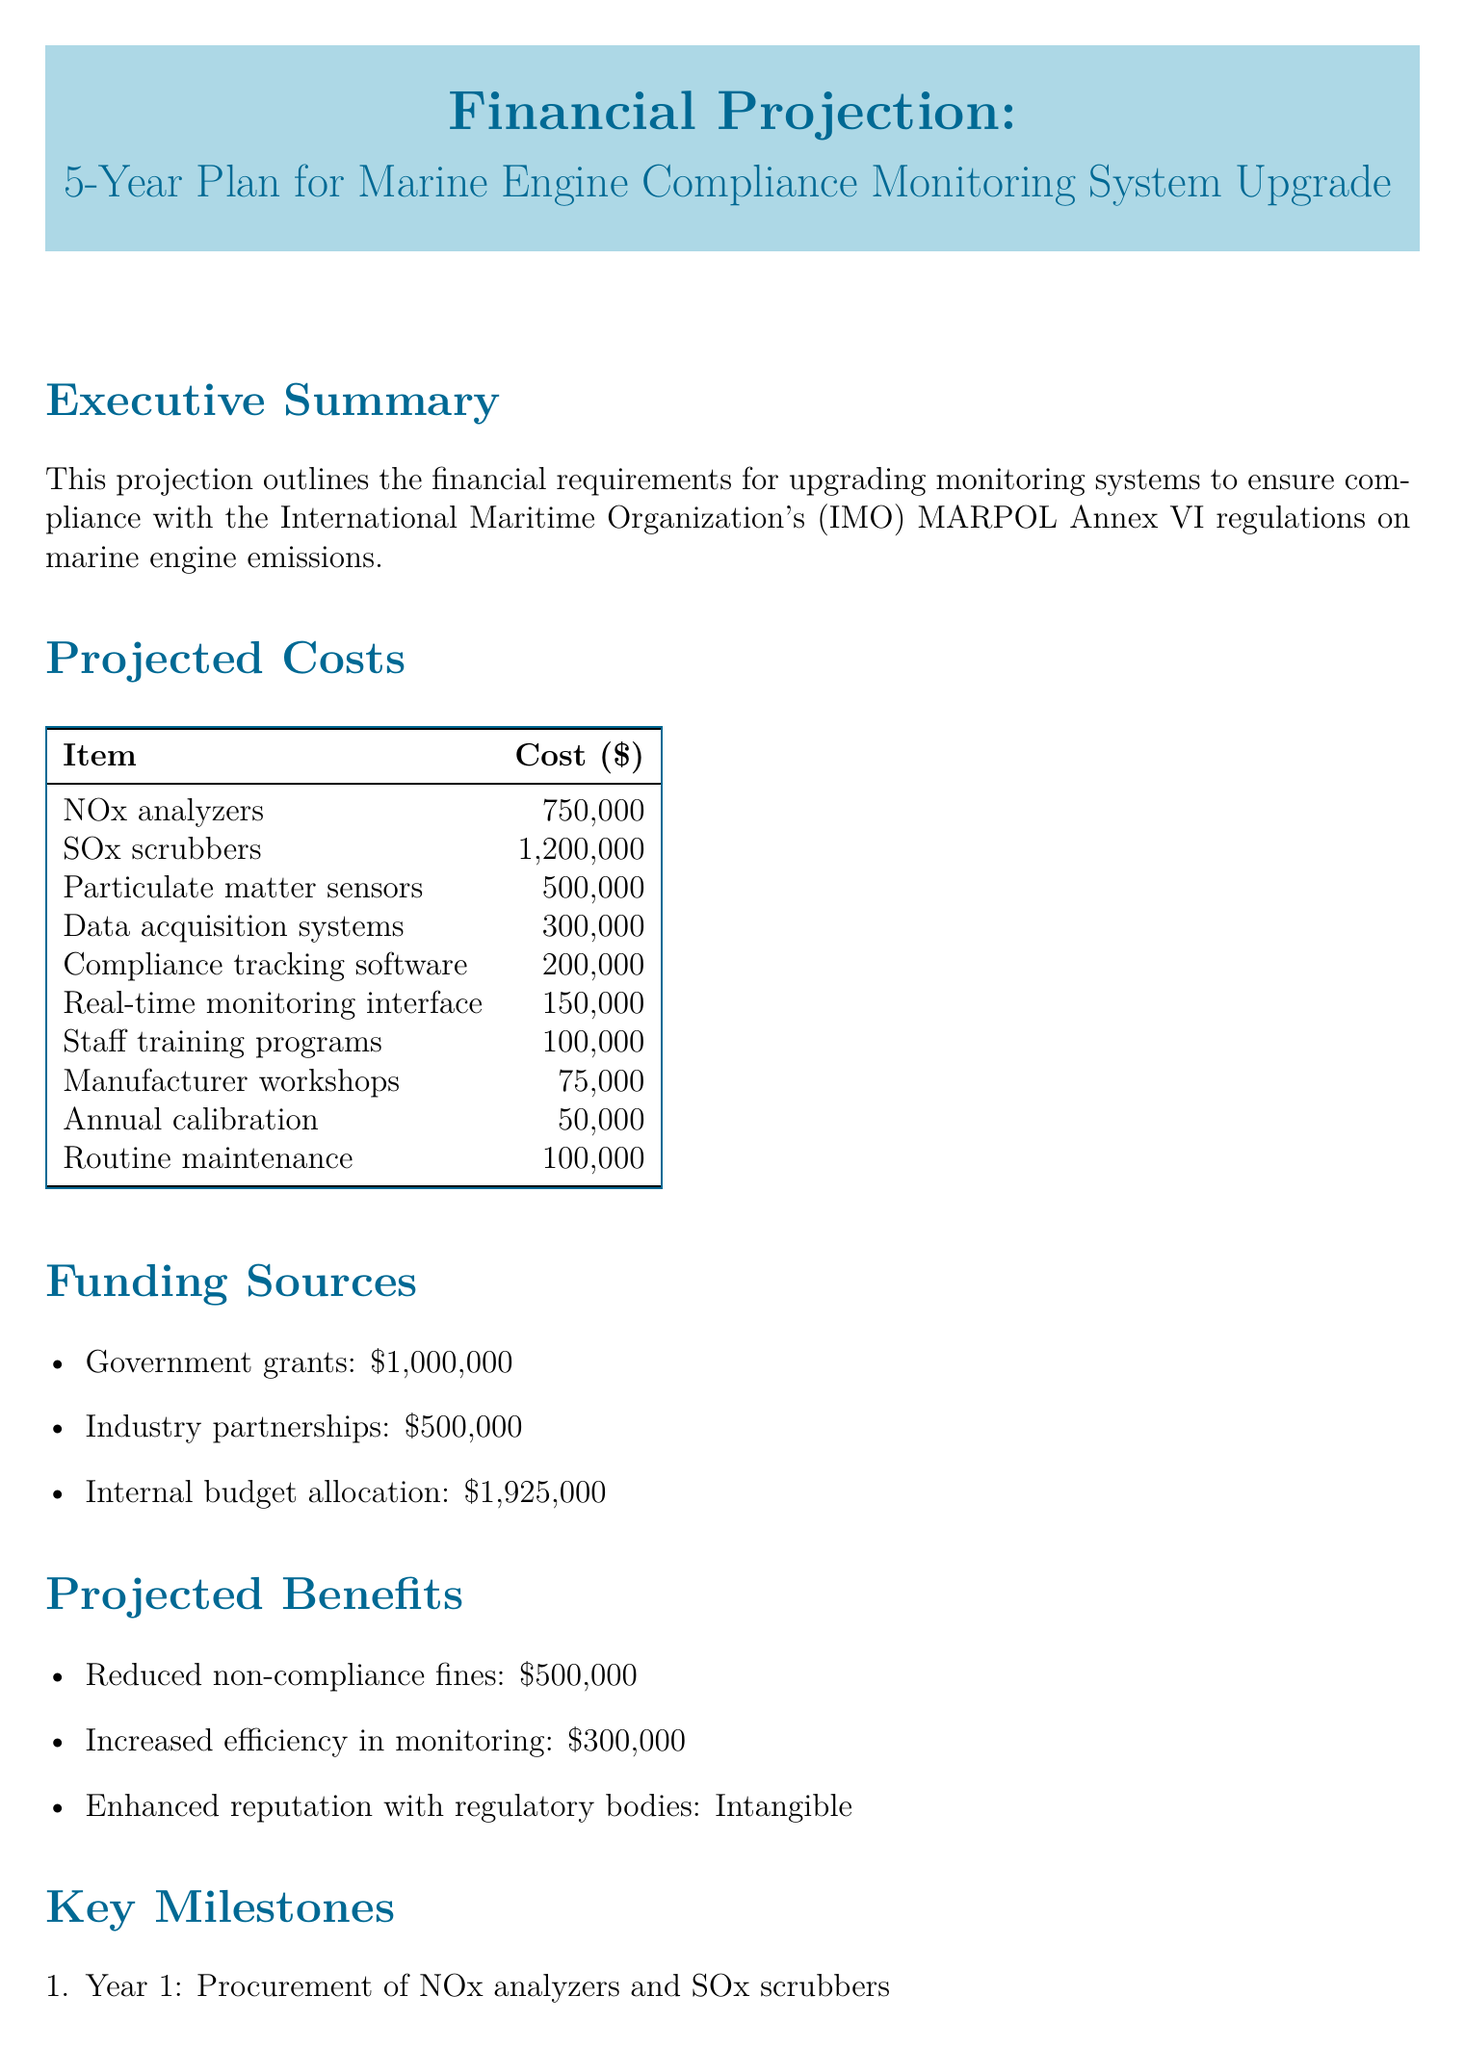What is the total cost of NOx analyzers? The cost for NOx analyzers is listed as $750,000 in the projected costs section.
Answer: $750,000 What is the funding source that contributes the most? The internal budget allocation is the largest funding source at $1,925,000.
Answer: $1,925,000 How much will be spent on staff training programs? Staff training programs will cost $100,000 as indicated in the projected costs section.
Answer: $100,000 What is the projected benefit from reduced non-compliance fines? The document states that the projected benefit from reduced non-compliance fines is $500,000.
Answer: $500,000 What action is planned for Year 3? The action for Year 3 is the implementation of compliance tracking software as per the key milestones section.
Answer: Implementation of compliance tracking software What is the risk level associated with technology obsolescence? The document assesses the risk level of technology obsolescence as low.
Answer: Low What is the estimated cost for SOx scrubbers? The estimated cost for SOx scrubbers is listed at $1,200,000 in the projected costs section.
Answer: $1,200,000 What is the intangible projected benefit mentioned? The enhanced reputation with regulatory bodies is noted as an intangible benefit in the projected benefits section.
Answer: Intangible 